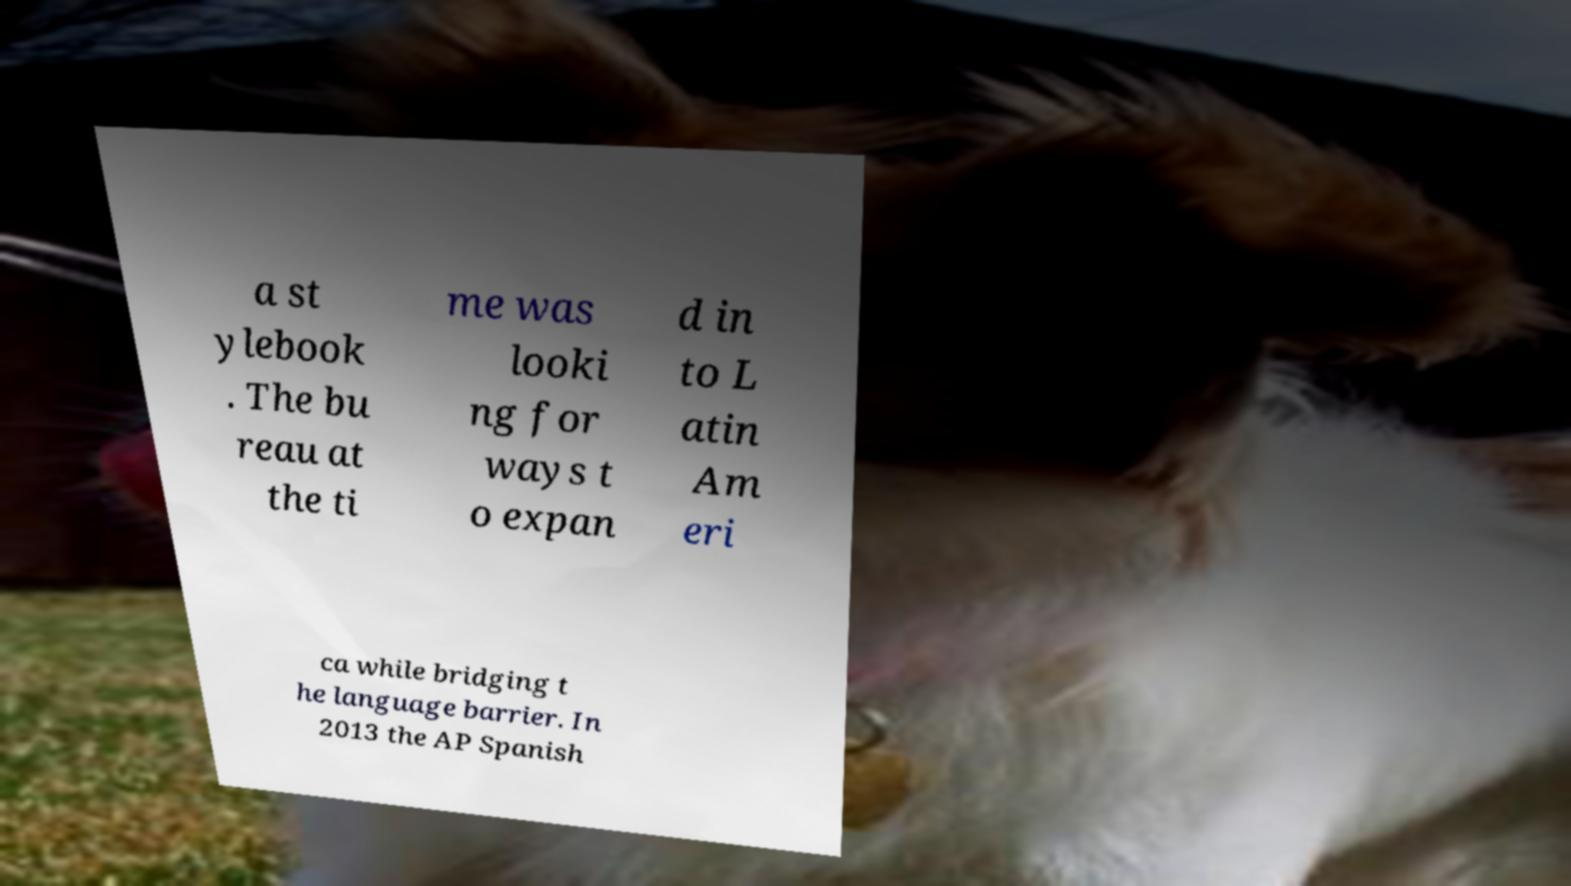Could you assist in decoding the text presented in this image and type it out clearly? a st ylebook . The bu reau at the ti me was looki ng for ways t o expan d in to L atin Am eri ca while bridging t he language barrier. In 2013 the AP Spanish 